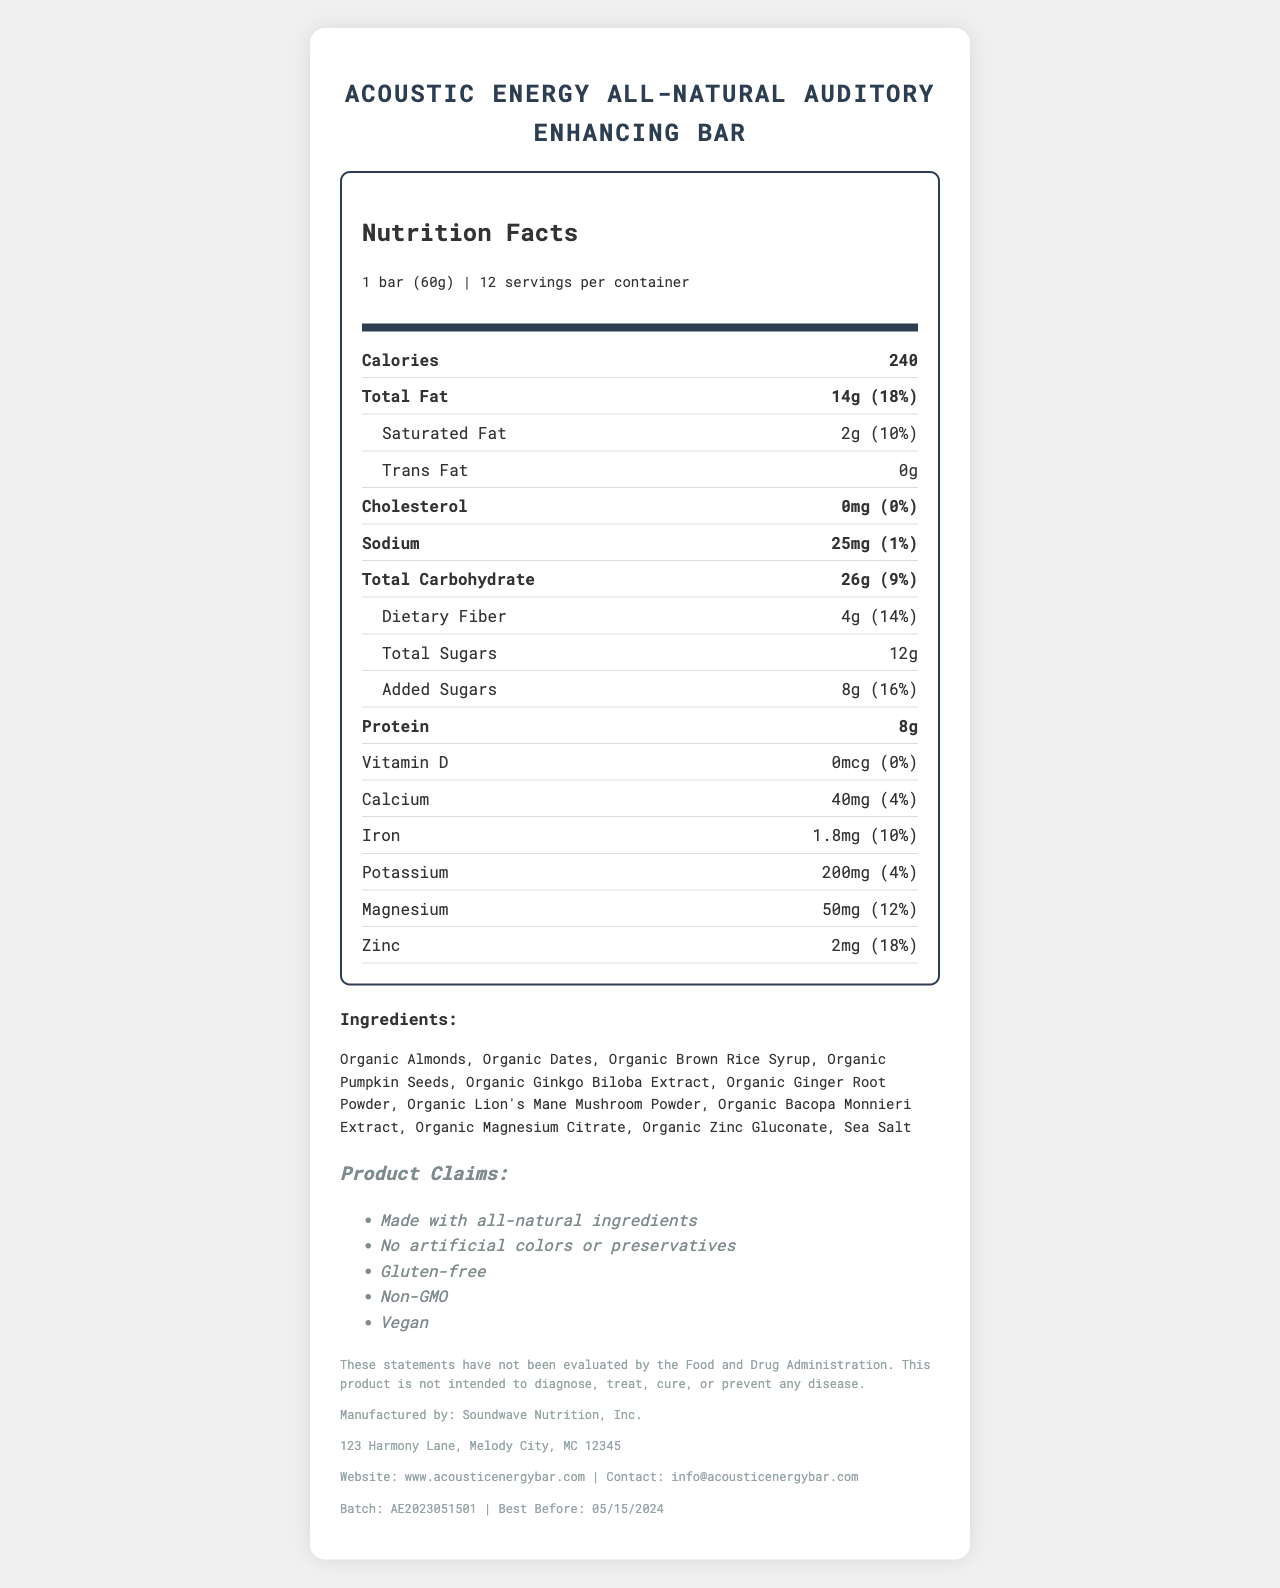Is the Acoustic Energy All-Natural Auditory Enhancing Bar gluten-free? The document lists "Gluten-free" under the claims section.
Answer: Yes How many calories are in one bar? The nutrition label states that one serving (1 bar) contains 240 calories.
Answer: 240 What is the total fat content per serving? The nutrition label shows that the total fat content per serving is 14g.
Answer: 14g How much sugar is added to each bar? The nutrition label under "Added Sugars" specifies that there are 8g of added sugars per serving.
Answer: 8g How much protein is in one bar? The nutrition label indicates that each bar contains 8g of protein.
Answer: 8g What are the ingredients in the "Auditory Boost Blend"? The ingredients for the "Auditory Boost Blend" are listed as Ginkgo Biloba Extract, Lion's Mane Mushroom Powder, and Bacopa Monnieri Extract.
Answer: Ginkgo Biloba Extract, Lion's Mane Mushroom Powder, Bacopa Monnieri Extract Does the bar contain any common allergens? The allergen information states that the bar contains almonds and is manufactured in a facility that processes other tree nuts, peanuts, soy, and milk.
Answer: Yes What is the serving size for "Acoustic Energy All-Natural Auditory Enhancing Bar"? The serving size is listed as 1 bar (60g).
Answer: 1 bar (60g) Which company manufactures Acoustic Energy Bars? The document states that the manufacturer is Soundwave Nutrition, Inc.
Answer: Soundwave Nutrition, Inc. How much of the daily recommended iron intake does one bar provide? The nutrition label shows that one bar provides 10% of the daily value for iron.
Answer: 10% What is the best before date for this product? The document lists the best before date as 05/15/2024.
Answer: 05/15/2024 What percentage of the daily value for calcium does each bar provide? The nutrition label indicates that one bar provides 4% of the daily value for calcium.
Answer: 4% Which of the following is not an ingredient in the bar? 
A. Organic Almonds 
B. Organic Brown Rice Syrup 
C. Organic Cocoa 
D. Organic Ginger Root Powder The ingredients list does not include Organic Cocoa.
Answer: C. Organic Cocoa How many servings are there in one container? 
A. 10 
B. 12 
C. 16 
D. 20 The document states that there are 12 servings per container.
Answer: B. 12 Are the statements about the product evaluated by the Food and Drug Administration (FDA)? The disclaimer states that these statements have not been evaluated by the FDA.
Answer: No Summarize the main features of the Acoustic Energy all-natural energy bars. The summary highlights the key features of the document, including nutritional information, ingredients, product claims, manufacturer details, and storage instructions.
Answer: The Acoustic Energy all-natural energy bars are designed to enhance auditory perception and contain all-natural ingredients. Each bar has 240 calories, 14g of fat, 26g of carbohydrates, and 8g of protein. The product claims include being gluten-free, vegan, non-GMO, and free of artificial colors and preservatives. The "Auditory Boost Blend" includes Ginkgo Biloba Extract, Lion's Mane Mushroom Powder, and Bacopa Monnieri Extract. The bars are made by Soundwave Nutrition, Inc. and should be stored in a cool, dry place. The product is not evaluated by the FDA. What time of the day is best to consume Acoustic Energy Bars for optimal auditory perception? The document does not provide any information regarding the optimal time of day to consume the bars for auditory enhancement.
Answer: Cannot be determined 